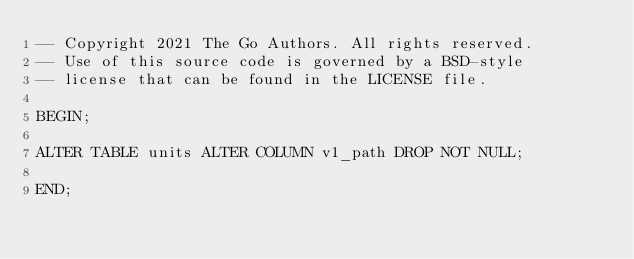Convert code to text. <code><loc_0><loc_0><loc_500><loc_500><_SQL_>-- Copyright 2021 The Go Authors. All rights reserved.
-- Use of this source code is governed by a BSD-style
-- license that can be found in the LICENSE file.

BEGIN;

ALTER TABLE units ALTER COLUMN v1_path DROP NOT NULL;

END;
</code> 